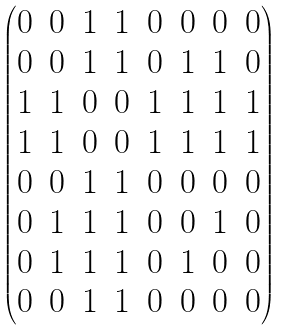<formula> <loc_0><loc_0><loc_500><loc_500>\begin{pmatrix} 0 & 0 & 1 & 1 & 0 & 0 & 0 & 0 \\ 0 & 0 & 1 & 1 & 0 & 1 & 1 & 0 \\ 1 & 1 & 0 & 0 & 1 & 1 & 1 & 1 \\ 1 & 1 & 0 & 0 & 1 & 1 & 1 & 1 \\ 0 & 0 & 1 & 1 & 0 & 0 & 0 & 0 \\ 0 & 1 & 1 & 1 & 0 & 0 & 1 & 0 \\ 0 & 1 & 1 & 1 & 0 & 1 & 0 & 0 \\ 0 & 0 & 1 & 1 & 0 & 0 & 0 & 0 \end{pmatrix}</formula> 